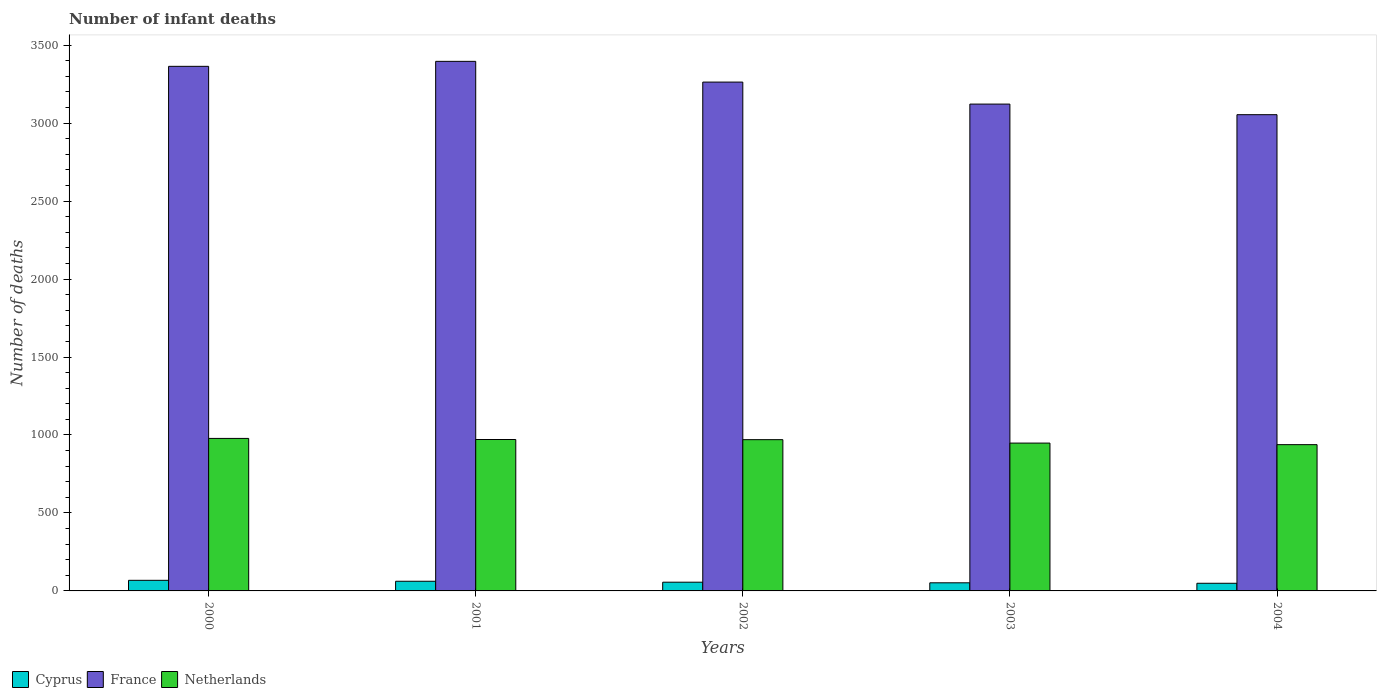How many different coloured bars are there?
Offer a very short reply. 3. Are the number of bars on each tick of the X-axis equal?
Your response must be concise. Yes. How many bars are there on the 4th tick from the right?
Give a very brief answer. 3. What is the label of the 1st group of bars from the left?
Provide a short and direct response. 2000. What is the number of infant deaths in France in 2000?
Offer a very short reply. 3364. Across all years, what is the maximum number of infant deaths in France?
Your answer should be very brief. 3396. Across all years, what is the minimum number of infant deaths in Netherlands?
Your answer should be very brief. 938. In which year was the number of infant deaths in Cyprus minimum?
Your response must be concise. 2004. What is the total number of infant deaths in Cyprus in the graph?
Your answer should be very brief. 287. What is the difference between the number of infant deaths in Netherlands in 2000 and that in 2002?
Keep it short and to the point. 8. What is the difference between the number of infant deaths in Netherlands in 2003 and the number of infant deaths in France in 2004?
Your response must be concise. -2106. What is the average number of infant deaths in Cyprus per year?
Offer a very short reply. 57.4. In the year 2003, what is the difference between the number of infant deaths in Cyprus and number of infant deaths in France?
Offer a very short reply. -3070. What is the ratio of the number of infant deaths in Cyprus in 2000 to that in 2003?
Make the answer very short. 1.31. What is the difference between the highest and the second highest number of infant deaths in Netherlands?
Ensure brevity in your answer.  7. What is the difference between the highest and the lowest number of infant deaths in France?
Offer a terse response. 342. What does the 2nd bar from the left in 2002 represents?
Give a very brief answer. France. How many bars are there?
Provide a short and direct response. 15. How many years are there in the graph?
Your response must be concise. 5. Does the graph contain any zero values?
Your answer should be compact. No. What is the title of the graph?
Keep it short and to the point. Number of infant deaths. Does "Iraq" appear as one of the legend labels in the graph?
Ensure brevity in your answer.  No. What is the label or title of the X-axis?
Your answer should be compact. Years. What is the label or title of the Y-axis?
Provide a short and direct response. Number of deaths. What is the Number of deaths in France in 2000?
Keep it short and to the point. 3364. What is the Number of deaths of Netherlands in 2000?
Your response must be concise. 978. What is the Number of deaths of France in 2001?
Your answer should be compact. 3396. What is the Number of deaths of Netherlands in 2001?
Offer a terse response. 971. What is the Number of deaths in Cyprus in 2002?
Your answer should be very brief. 56. What is the Number of deaths in France in 2002?
Ensure brevity in your answer.  3263. What is the Number of deaths of Netherlands in 2002?
Provide a succinct answer. 970. What is the Number of deaths of Cyprus in 2003?
Provide a succinct answer. 52. What is the Number of deaths of France in 2003?
Keep it short and to the point. 3122. What is the Number of deaths in Netherlands in 2003?
Your answer should be compact. 948. What is the Number of deaths of Cyprus in 2004?
Your answer should be compact. 49. What is the Number of deaths of France in 2004?
Ensure brevity in your answer.  3054. What is the Number of deaths in Netherlands in 2004?
Make the answer very short. 938. Across all years, what is the maximum Number of deaths in Cyprus?
Offer a terse response. 68. Across all years, what is the maximum Number of deaths in France?
Your response must be concise. 3396. Across all years, what is the maximum Number of deaths of Netherlands?
Your answer should be very brief. 978. Across all years, what is the minimum Number of deaths in Cyprus?
Provide a succinct answer. 49. Across all years, what is the minimum Number of deaths of France?
Keep it short and to the point. 3054. Across all years, what is the minimum Number of deaths in Netherlands?
Offer a terse response. 938. What is the total Number of deaths in Cyprus in the graph?
Offer a very short reply. 287. What is the total Number of deaths of France in the graph?
Offer a very short reply. 1.62e+04. What is the total Number of deaths in Netherlands in the graph?
Offer a terse response. 4805. What is the difference between the Number of deaths in Cyprus in 2000 and that in 2001?
Provide a succinct answer. 6. What is the difference between the Number of deaths in France in 2000 and that in 2001?
Your response must be concise. -32. What is the difference between the Number of deaths of Netherlands in 2000 and that in 2001?
Offer a very short reply. 7. What is the difference between the Number of deaths in Cyprus in 2000 and that in 2002?
Provide a short and direct response. 12. What is the difference between the Number of deaths of France in 2000 and that in 2002?
Provide a short and direct response. 101. What is the difference between the Number of deaths of France in 2000 and that in 2003?
Provide a short and direct response. 242. What is the difference between the Number of deaths of Netherlands in 2000 and that in 2003?
Provide a short and direct response. 30. What is the difference between the Number of deaths in Cyprus in 2000 and that in 2004?
Ensure brevity in your answer.  19. What is the difference between the Number of deaths of France in 2000 and that in 2004?
Your answer should be compact. 310. What is the difference between the Number of deaths of Cyprus in 2001 and that in 2002?
Keep it short and to the point. 6. What is the difference between the Number of deaths in France in 2001 and that in 2002?
Keep it short and to the point. 133. What is the difference between the Number of deaths in France in 2001 and that in 2003?
Your response must be concise. 274. What is the difference between the Number of deaths of Netherlands in 2001 and that in 2003?
Make the answer very short. 23. What is the difference between the Number of deaths in Cyprus in 2001 and that in 2004?
Your response must be concise. 13. What is the difference between the Number of deaths in France in 2001 and that in 2004?
Keep it short and to the point. 342. What is the difference between the Number of deaths of Netherlands in 2001 and that in 2004?
Keep it short and to the point. 33. What is the difference between the Number of deaths in France in 2002 and that in 2003?
Your answer should be very brief. 141. What is the difference between the Number of deaths in Netherlands in 2002 and that in 2003?
Offer a very short reply. 22. What is the difference between the Number of deaths of France in 2002 and that in 2004?
Make the answer very short. 209. What is the difference between the Number of deaths of Cyprus in 2000 and the Number of deaths of France in 2001?
Offer a very short reply. -3328. What is the difference between the Number of deaths in Cyprus in 2000 and the Number of deaths in Netherlands in 2001?
Give a very brief answer. -903. What is the difference between the Number of deaths of France in 2000 and the Number of deaths of Netherlands in 2001?
Keep it short and to the point. 2393. What is the difference between the Number of deaths in Cyprus in 2000 and the Number of deaths in France in 2002?
Offer a terse response. -3195. What is the difference between the Number of deaths of Cyprus in 2000 and the Number of deaths of Netherlands in 2002?
Offer a terse response. -902. What is the difference between the Number of deaths of France in 2000 and the Number of deaths of Netherlands in 2002?
Ensure brevity in your answer.  2394. What is the difference between the Number of deaths in Cyprus in 2000 and the Number of deaths in France in 2003?
Ensure brevity in your answer.  -3054. What is the difference between the Number of deaths of Cyprus in 2000 and the Number of deaths of Netherlands in 2003?
Offer a terse response. -880. What is the difference between the Number of deaths in France in 2000 and the Number of deaths in Netherlands in 2003?
Make the answer very short. 2416. What is the difference between the Number of deaths of Cyprus in 2000 and the Number of deaths of France in 2004?
Keep it short and to the point. -2986. What is the difference between the Number of deaths of Cyprus in 2000 and the Number of deaths of Netherlands in 2004?
Provide a short and direct response. -870. What is the difference between the Number of deaths in France in 2000 and the Number of deaths in Netherlands in 2004?
Your response must be concise. 2426. What is the difference between the Number of deaths in Cyprus in 2001 and the Number of deaths in France in 2002?
Your answer should be compact. -3201. What is the difference between the Number of deaths of Cyprus in 2001 and the Number of deaths of Netherlands in 2002?
Make the answer very short. -908. What is the difference between the Number of deaths in France in 2001 and the Number of deaths in Netherlands in 2002?
Your response must be concise. 2426. What is the difference between the Number of deaths in Cyprus in 2001 and the Number of deaths in France in 2003?
Keep it short and to the point. -3060. What is the difference between the Number of deaths of Cyprus in 2001 and the Number of deaths of Netherlands in 2003?
Offer a terse response. -886. What is the difference between the Number of deaths in France in 2001 and the Number of deaths in Netherlands in 2003?
Offer a very short reply. 2448. What is the difference between the Number of deaths of Cyprus in 2001 and the Number of deaths of France in 2004?
Your response must be concise. -2992. What is the difference between the Number of deaths of Cyprus in 2001 and the Number of deaths of Netherlands in 2004?
Make the answer very short. -876. What is the difference between the Number of deaths in France in 2001 and the Number of deaths in Netherlands in 2004?
Your answer should be compact. 2458. What is the difference between the Number of deaths in Cyprus in 2002 and the Number of deaths in France in 2003?
Offer a terse response. -3066. What is the difference between the Number of deaths in Cyprus in 2002 and the Number of deaths in Netherlands in 2003?
Offer a terse response. -892. What is the difference between the Number of deaths in France in 2002 and the Number of deaths in Netherlands in 2003?
Your answer should be compact. 2315. What is the difference between the Number of deaths in Cyprus in 2002 and the Number of deaths in France in 2004?
Offer a very short reply. -2998. What is the difference between the Number of deaths in Cyprus in 2002 and the Number of deaths in Netherlands in 2004?
Make the answer very short. -882. What is the difference between the Number of deaths in France in 2002 and the Number of deaths in Netherlands in 2004?
Keep it short and to the point. 2325. What is the difference between the Number of deaths of Cyprus in 2003 and the Number of deaths of France in 2004?
Your answer should be very brief. -3002. What is the difference between the Number of deaths of Cyprus in 2003 and the Number of deaths of Netherlands in 2004?
Ensure brevity in your answer.  -886. What is the difference between the Number of deaths of France in 2003 and the Number of deaths of Netherlands in 2004?
Offer a very short reply. 2184. What is the average Number of deaths in Cyprus per year?
Give a very brief answer. 57.4. What is the average Number of deaths of France per year?
Give a very brief answer. 3239.8. What is the average Number of deaths in Netherlands per year?
Ensure brevity in your answer.  961. In the year 2000, what is the difference between the Number of deaths in Cyprus and Number of deaths in France?
Provide a short and direct response. -3296. In the year 2000, what is the difference between the Number of deaths of Cyprus and Number of deaths of Netherlands?
Make the answer very short. -910. In the year 2000, what is the difference between the Number of deaths of France and Number of deaths of Netherlands?
Your answer should be compact. 2386. In the year 2001, what is the difference between the Number of deaths of Cyprus and Number of deaths of France?
Provide a succinct answer. -3334. In the year 2001, what is the difference between the Number of deaths in Cyprus and Number of deaths in Netherlands?
Give a very brief answer. -909. In the year 2001, what is the difference between the Number of deaths in France and Number of deaths in Netherlands?
Give a very brief answer. 2425. In the year 2002, what is the difference between the Number of deaths in Cyprus and Number of deaths in France?
Provide a succinct answer. -3207. In the year 2002, what is the difference between the Number of deaths of Cyprus and Number of deaths of Netherlands?
Your answer should be very brief. -914. In the year 2002, what is the difference between the Number of deaths in France and Number of deaths in Netherlands?
Offer a terse response. 2293. In the year 2003, what is the difference between the Number of deaths in Cyprus and Number of deaths in France?
Offer a terse response. -3070. In the year 2003, what is the difference between the Number of deaths in Cyprus and Number of deaths in Netherlands?
Make the answer very short. -896. In the year 2003, what is the difference between the Number of deaths of France and Number of deaths of Netherlands?
Make the answer very short. 2174. In the year 2004, what is the difference between the Number of deaths of Cyprus and Number of deaths of France?
Your answer should be very brief. -3005. In the year 2004, what is the difference between the Number of deaths of Cyprus and Number of deaths of Netherlands?
Give a very brief answer. -889. In the year 2004, what is the difference between the Number of deaths in France and Number of deaths in Netherlands?
Your answer should be very brief. 2116. What is the ratio of the Number of deaths in Cyprus in 2000 to that in 2001?
Your answer should be compact. 1.1. What is the ratio of the Number of deaths in France in 2000 to that in 2001?
Your answer should be very brief. 0.99. What is the ratio of the Number of deaths in Cyprus in 2000 to that in 2002?
Provide a succinct answer. 1.21. What is the ratio of the Number of deaths in France in 2000 to that in 2002?
Provide a short and direct response. 1.03. What is the ratio of the Number of deaths in Netherlands in 2000 to that in 2002?
Make the answer very short. 1.01. What is the ratio of the Number of deaths of Cyprus in 2000 to that in 2003?
Give a very brief answer. 1.31. What is the ratio of the Number of deaths in France in 2000 to that in 2003?
Give a very brief answer. 1.08. What is the ratio of the Number of deaths of Netherlands in 2000 to that in 2003?
Ensure brevity in your answer.  1.03. What is the ratio of the Number of deaths in Cyprus in 2000 to that in 2004?
Make the answer very short. 1.39. What is the ratio of the Number of deaths of France in 2000 to that in 2004?
Provide a short and direct response. 1.1. What is the ratio of the Number of deaths of Netherlands in 2000 to that in 2004?
Provide a succinct answer. 1.04. What is the ratio of the Number of deaths of Cyprus in 2001 to that in 2002?
Make the answer very short. 1.11. What is the ratio of the Number of deaths in France in 2001 to that in 2002?
Provide a succinct answer. 1.04. What is the ratio of the Number of deaths of Cyprus in 2001 to that in 2003?
Provide a succinct answer. 1.19. What is the ratio of the Number of deaths of France in 2001 to that in 2003?
Offer a very short reply. 1.09. What is the ratio of the Number of deaths of Netherlands in 2001 to that in 2003?
Offer a very short reply. 1.02. What is the ratio of the Number of deaths of Cyprus in 2001 to that in 2004?
Make the answer very short. 1.27. What is the ratio of the Number of deaths of France in 2001 to that in 2004?
Offer a very short reply. 1.11. What is the ratio of the Number of deaths in Netherlands in 2001 to that in 2004?
Make the answer very short. 1.04. What is the ratio of the Number of deaths of France in 2002 to that in 2003?
Keep it short and to the point. 1.05. What is the ratio of the Number of deaths of Netherlands in 2002 to that in 2003?
Provide a short and direct response. 1.02. What is the ratio of the Number of deaths in France in 2002 to that in 2004?
Offer a terse response. 1.07. What is the ratio of the Number of deaths in Netherlands in 2002 to that in 2004?
Provide a succinct answer. 1.03. What is the ratio of the Number of deaths of Cyprus in 2003 to that in 2004?
Provide a succinct answer. 1.06. What is the ratio of the Number of deaths of France in 2003 to that in 2004?
Your response must be concise. 1.02. What is the ratio of the Number of deaths in Netherlands in 2003 to that in 2004?
Keep it short and to the point. 1.01. What is the difference between the highest and the second highest Number of deaths of Cyprus?
Your response must be concise. 6. What is the difference between the highest and the second highest Number of deaths of France?
Ensure brevity in your answer.  32. What is the difference between the highest and the lowest Number of deaths in France?
Ensure brevity in your answer.  342. 